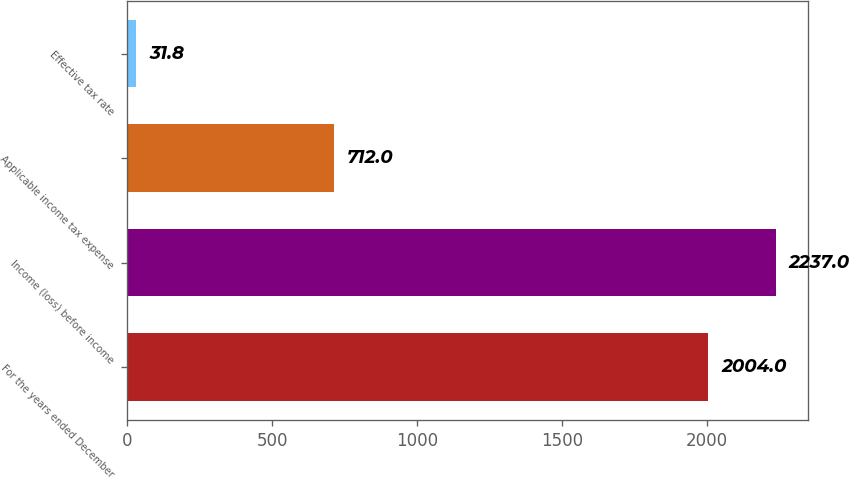Convert chart. <chart><loc_0><loc_0><loc_500><loc_500><bar_chart><fcel>For the years ended December<fcel>Income (loss) before income<fcel>Applicable income tax expense<fcel>Effective tax rate<nl><fcel>2004<fcel>2237<fcel>712<fcel>31.8<nl></chart> 